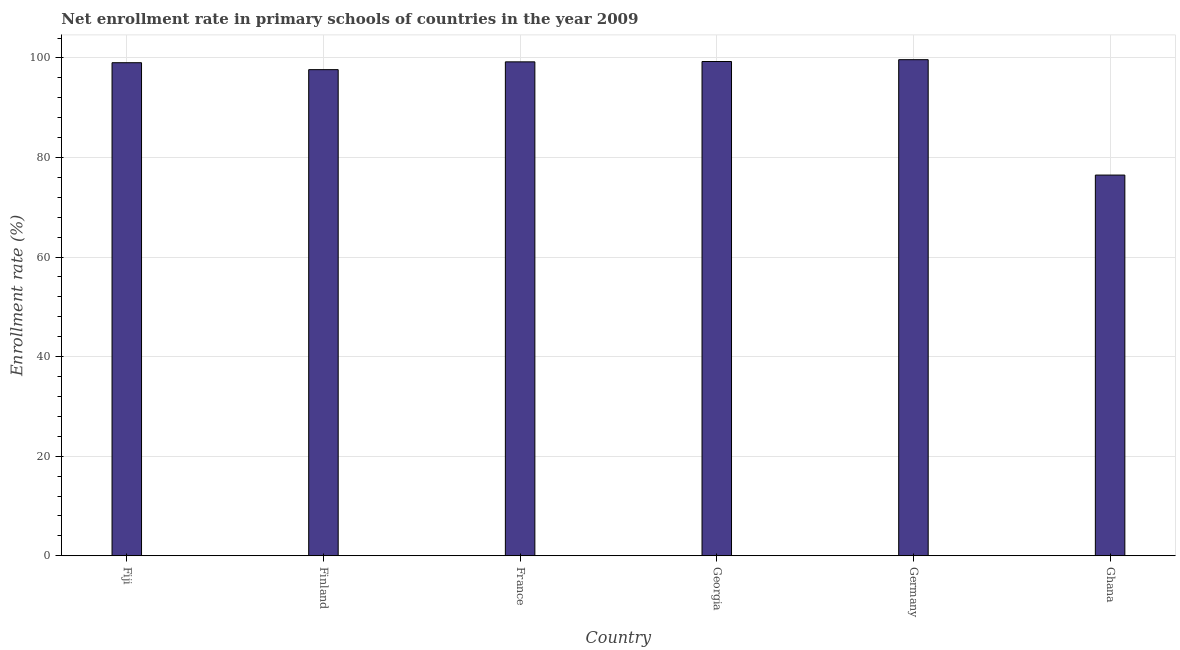Does the graph contain grids?
Your response must be concise. Yes. What is the title of the graph?
Ensure brevity in your answer.  Net enrollment rate in primary schools of countries in the year 2009. What is the label or title of the X-axis?
Provide a succinct answer. Country. What is the label or title of the Y-axis?
Make the answer very short. Enrollment rate (%). What is the net enrollment rate in primary schools in Ghana?
Give a very brief answer. 76.47. Across all countries, what is the maximum net enrollment rate in primary schools?
Ensure brevity in your answer.  99.65. Across all countries, what is the minimum net enrollment rate in primary schools?
Your answer should be very brief. 76.47. In which country was the net enrollment rate in primary schools maximum?
Your answer should be very brief. Germany. What is the sum of the net enrollment rate in primary schools?
Keep it short and to the point. 571.29. What is the difference between the net enrollment rate in primary schools in Fiji and Germany?
Give a very brief answer. -0.61. What is the average net enrollment rate in primary schools per country?
Make the answer very short. 95.21. What is the median net enrollment rate in primary schools?
Make the answer very short. 99.12. Is the net enrollment rate in primary schools in France less than that in Georgia?
Your response must be concise. Yes. Is the difference between the net enrollment rate in primary schools in Fiji and Georgia greater than the difference between any two countries?
Give a very brief answer. No. What is the difference between the highest and the second highest net enrollment rate in primary schools?
Your response must be concise. 0.37. What is the difference between the highest and the lowest net enrollment rate in primary schools?
Provide a succinct answer. 23.18. In how many countries, is the net enrollment rate in primary schools greater than the average net enrollment rate in primary schools taken over all countries?
Give a very brief answer. 5. How many bars are there?
Your answer should be compact. 6. Are all the bars in the graph horizontal?
Ensure brevity in your answer.  No. How many countries are there in the graph?
Ensure brevity in your answer.  6. What is the difference between two consecutive major ticks on the Y-axis?
Offer a terse response. 20. Are the values on the major ticks of Y-axis written in scientific E-notation?
Provide a succinct answer. No. What is the Enrollment rate (%) in Fiji?
Ensure brevity in your answer.  99.04. What is the Enrollment rate (%) in Finland?
Offer a very short reply. 97.64. What is the Enrollment rate (%) in France?
Ensure brevity in your answer.  99.21. What is the Enrollment rate (%) in Georgia?
Give a very brief answer. 99.28. What is the Enrollment rate (%) of Germany?
Offer a terse response. 99.65. What is the Enrollment rate (%) of Ghana?
Offer a very short reply. 76.47. What is the difference between the Enrollment rate (%) in Fiji and Finland?
Your answer should be compact. 1.39. What is the difference between the Enrollment rate (%) in Fiji and France?
Provide a succinct answer. -0.17. What is the difference between the Enrollment rate (%) in Fiji and Georgia?
Provide a short and direct response. -0.24. What is the difference between the Enrollment rate (%) in Fiji and Germany?
Keep it short and to the point. -0.61. What is the difference between the Enrollment rate (%) in Fiji and Ghana?
Make the answer very short. 22.57. What is the difference between the Enrollment rate (%) in Finland and France?
Provide a succinct answer. -1.57. What is the difference between the Enrollment rate (%) in Finland and Georgia?
Make the answer very short. -1.64. What is the difference between the Enrollment rate (%) in Finland and Germany?
Provide a succinct answer. -2. What is the difference between the Enrollment rate (%) in Finland and Ghana?
Provide a succinct answer. 21.18. What is the difference between the Enrollment rate (%) in France and Georgia?
Give a very brief answer. -0.07. What is the difference between the Enrollment rate (%) in France and Germany?
Offer a very short reply. -0.43. What is the difference between the Enrollment rate (%) in France and Ghana?
Your answer should be compact. 22.74. What is the difference between the Enrollment rate (%) in Georgia and Germany?
Offer a very short reply. -0.37. What is the difference between the Enrollment rate (%) in Georgia and Ghana?
Ensure brevity in your answer.  22.81. What is the difference between the Enrollment rate (%) in Germany and Ghana?
Your response must be concise. 23.18. What is the ratio of the Enrollment rate (%) in Fiji to that in France?
Keep it short and to the point. 1. What is the ratio of the Enrollment rate (%) in Fiji to that in Germany?
Offer a terse response. 0.99. What is the ratio of the Enrollment rate (%) in Fiji to that in Ghana?
Provide a succinct answer. 1.29. What is the ratio of the Enrollment rate (%) in Finland to that in France?
Give a very brief answer. 0.98. What is the ratio of the Enrollment rate (%) in Finland to that in Ghana?
Your answer should be compact. 1.28. What is the ratio of the Enrollment rate (%) in France to that in Germany?
Ensure brevity in your answer.  1. What is the ratio of the Enrollment rate (%) in France to that in Ghana?
Keep it short and to the point. 1.3. What is the ratio of the Enrollment rate (%) in Georgia to that in Germany?
Make the answer very short. 1. What is the ratio of the Enrollment rate (%) in Georgia to that in Ghana?
Offer a terse response. 1.3. What is the ratio of the Enrollment rate (%) in Germany to that in Ghana?
Your answer should be very brief. 1.3. 